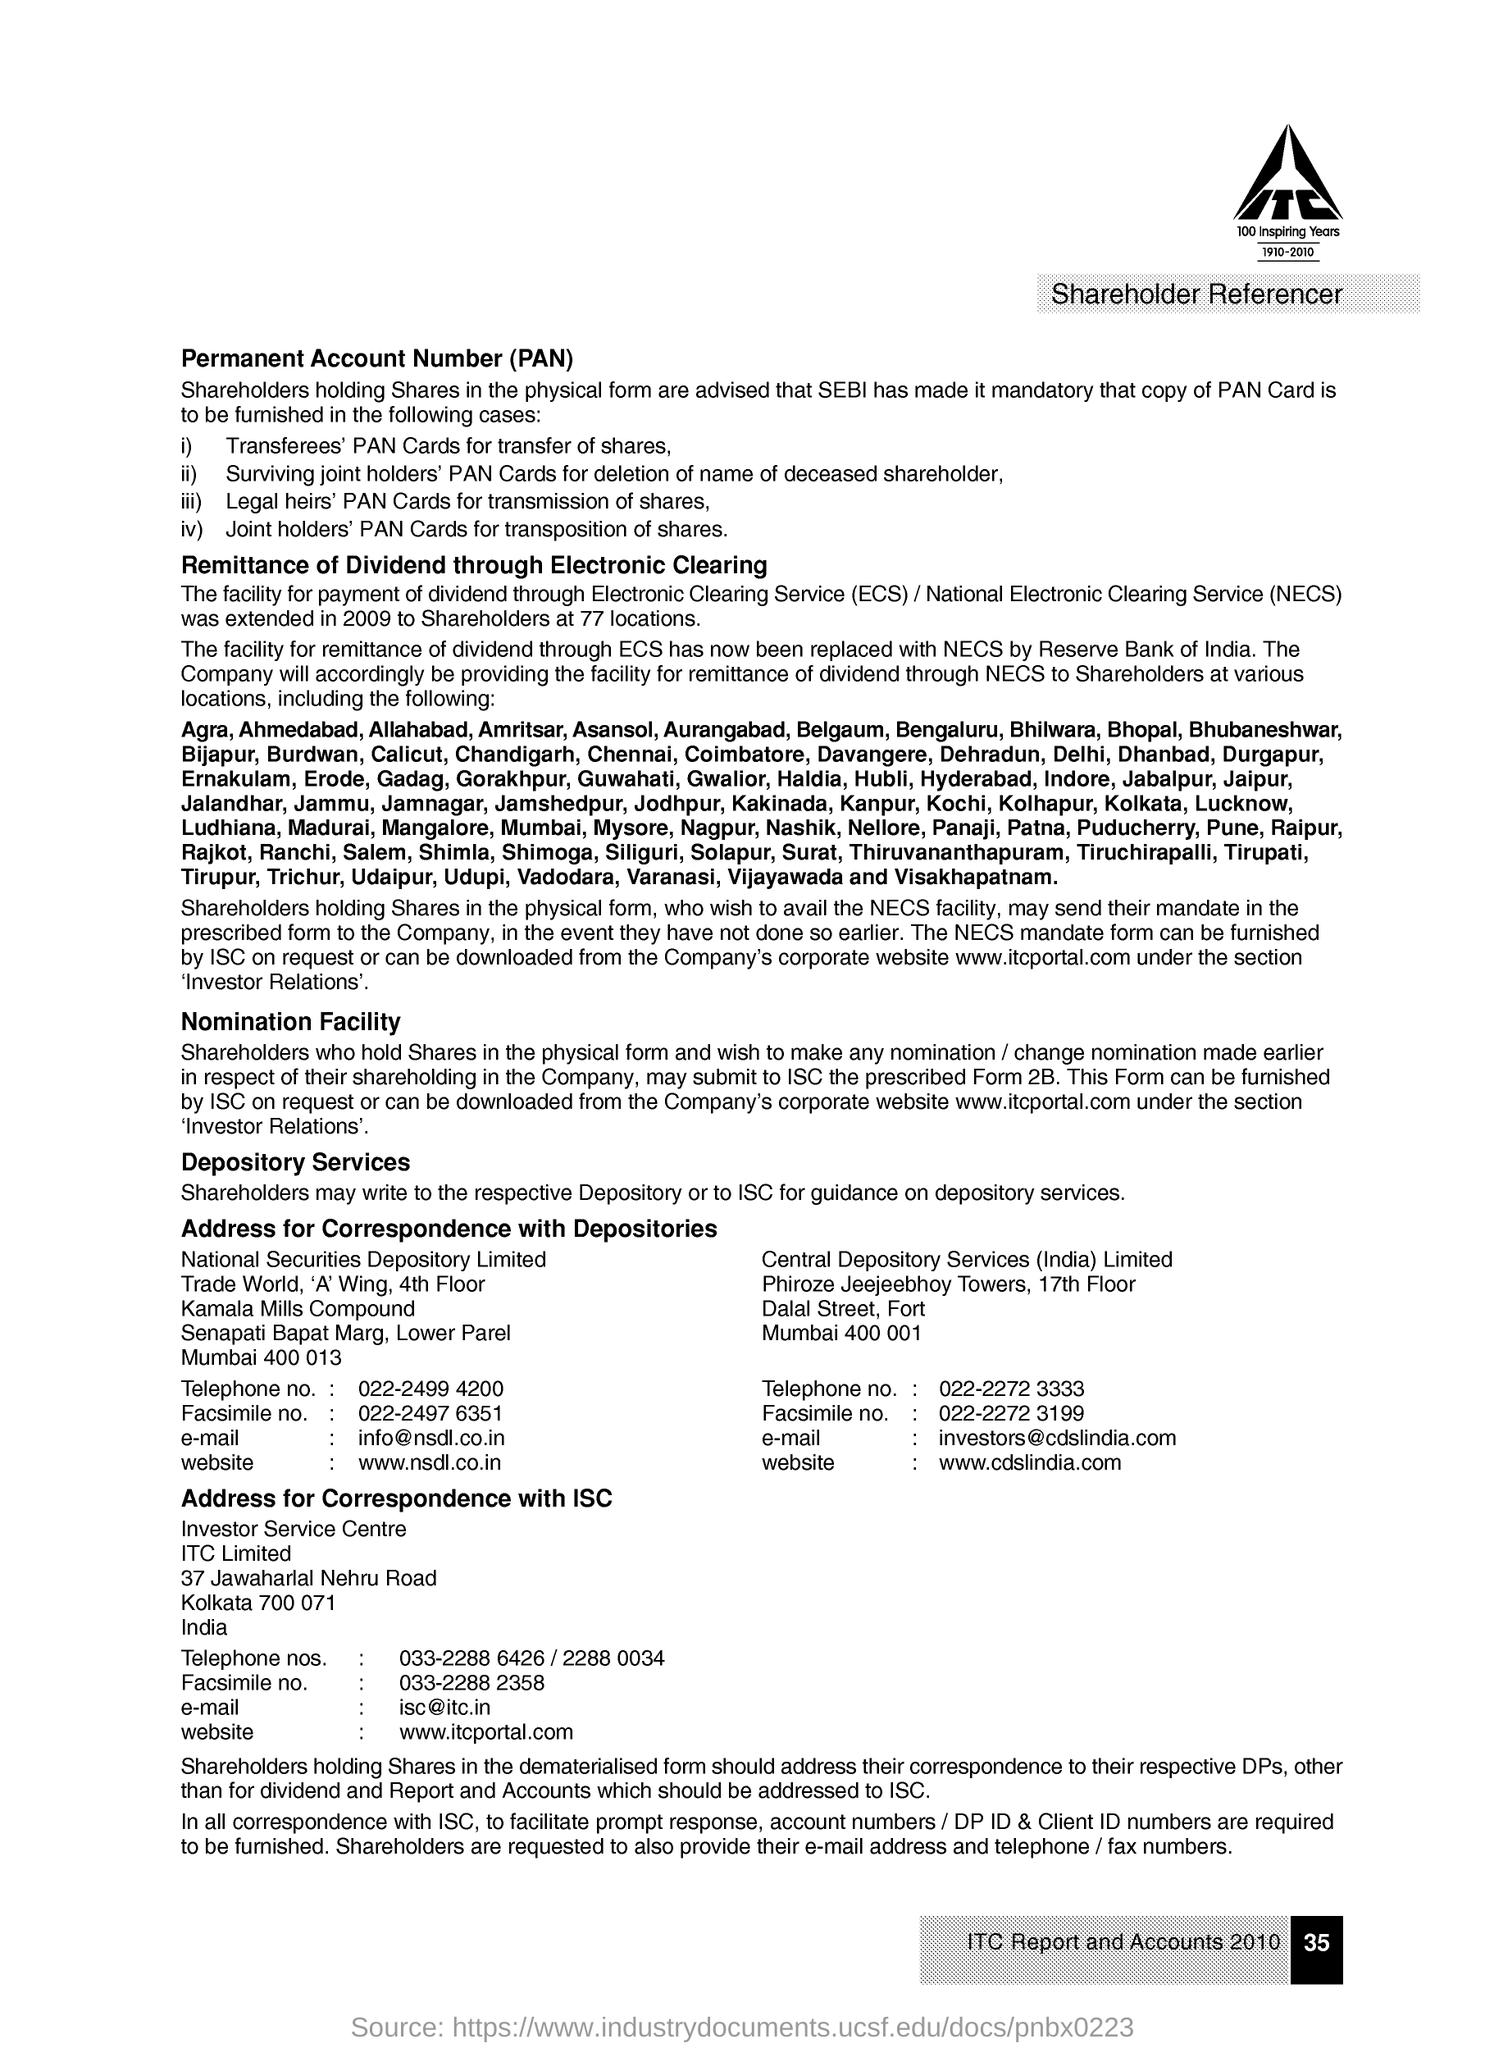Point out several critical features in this image. Permanent Account Number is commonly known as PAN. Electronic Clearing Service (ECS) is a system that facilitates electronic transfer of funds between banks in India. The payment of dividends is available at 77 locations for shareholders. 